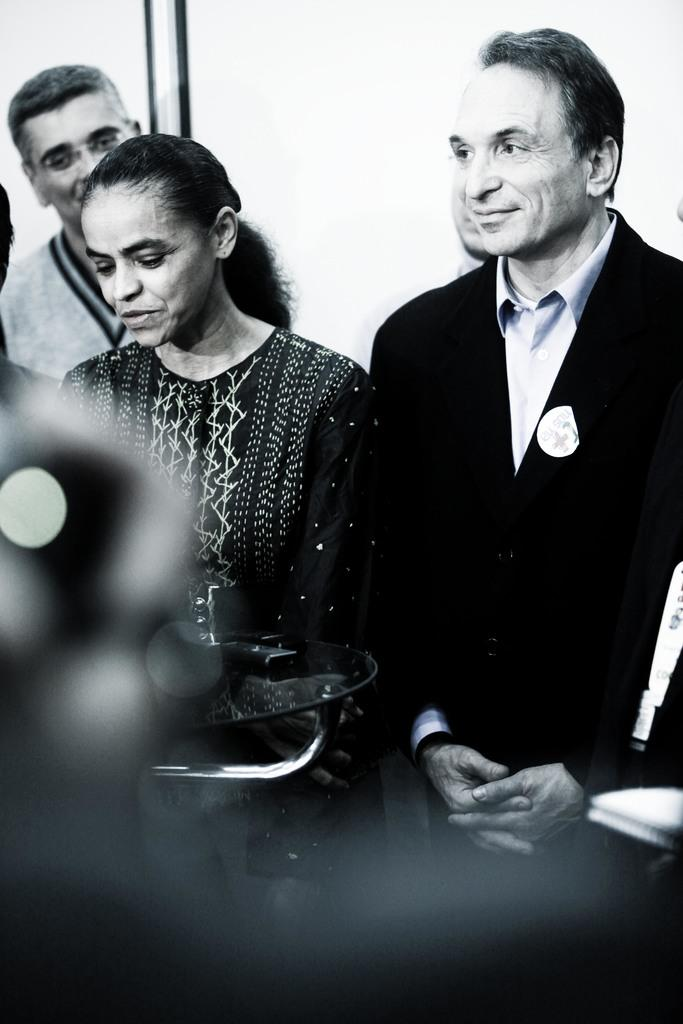What is the color scheme of the image? The image is black and white. How many people are in the image? There are a few people in the image. What is on the table in the image? There is a table with objects in the image. What can be seen in the background of the image? There is a wall visible in the background of the image. Can you see a chicken on the table in the image? No, there is no chicken present on the table or in the image. 